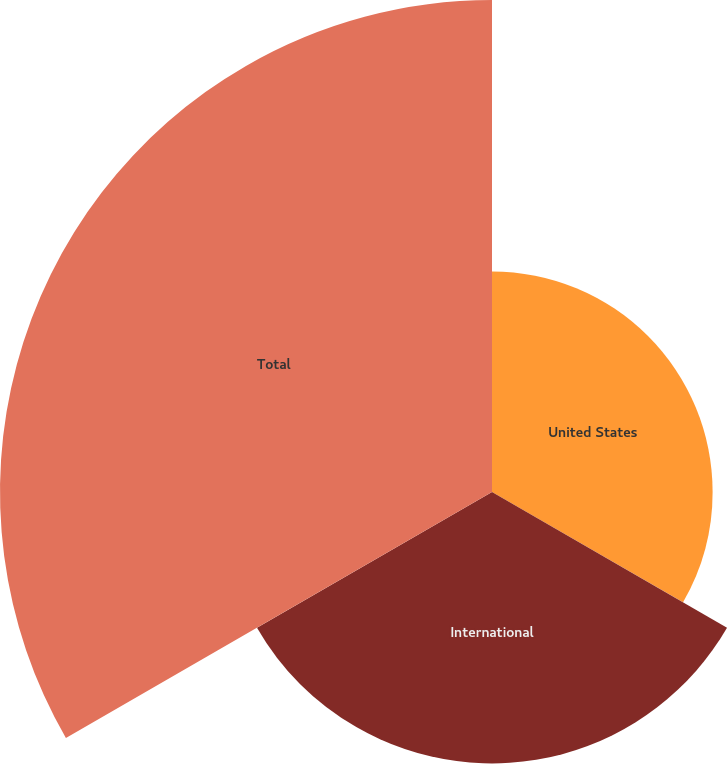<chart> <loc_0><loc_0><loc_500><loc_500><pie_chart><fcel>United States<fcel>International<fcel>Total<nl><fcel>22.42%<fcel>27.58%<fcel>50.0%<nl></chart> 